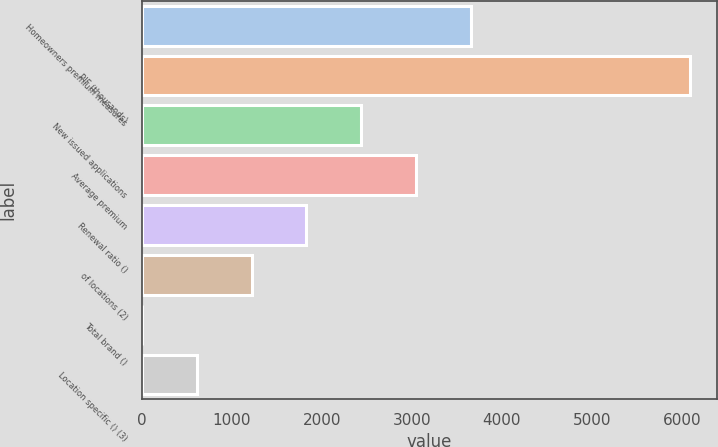<chart> <loc_0><loc_0><loc_500><loc_500><bar_chart><fcel>Homeowners premium measures<fcel>PIF (thousands)<fcel>New issued applications<fcel>Average premium<fcel>Renewal ratio ()<fcel>of locations (2)<fcel>Total brand ()<fcel>Location specific () (3)<nl><fcel>3653.52<fcel>6088<fcel>2436.28<fcel>3044.9<fcel>1827.66<fcel>1219.04<fcel>1.8<fcel>610.42<nl></chart> 